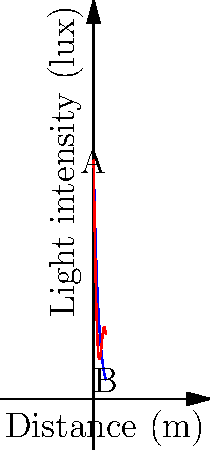A landscape photograph captures the variation in light intensity across a scene. The blue curve represents the ideal light intensity, given by $f(x) = 100e^{-0.5x}$, where $x$ is the distance in meters from the camera. The red curve shows the actual light intensity, affected by atmospheric conditions, given by $g(x) = 100e^{-0.5x} - 20\sin(x)$. At what distance from the camera is the rate of change of the actual light intensity the greatest? To find the distance where the rate of change of the actual light intensity is greatest, we need to follow these steps:

1) The rate of change of light intensity is given by the derivative of $g(x)$.

2) Calculate $g'(x)$:
   $$g'(x) = -50e^{-0.5x} - 20\cos(x)$$

3) To find the maximum rate of change, we need to find where $g''(x) = 0$:
   $$g''(x) = 25e^{-0.5x} + 20\sin(x)$$

4) Set $g''(x) = 0$:
   $$25e^{-0.5x} + 20\sin(x) = 0$$

5) This equation cannot be solved algebraically. We need to use numerical methods or graphing to find the solution.

6) Using a graphing calculator or computer software, we can find that the first positive solution to this equation is approximately $x \approx 1.37$ meters.

7) To confirm this is a maximum (not a minimum), we can check the sign of $g'''(x)$ at this point:
   $$g'''(x) = -12.5e^{-0.5x} + 20\cos(x)$$
   At $x = 1.37$, $g'''(1.37) \approx 5.76 > 0$, confirming a local maximum.

Therefore, the rate of change of the actual light intensity is greatest approximately 1.37 meters from the camera.
Answer: 1.37 meters 